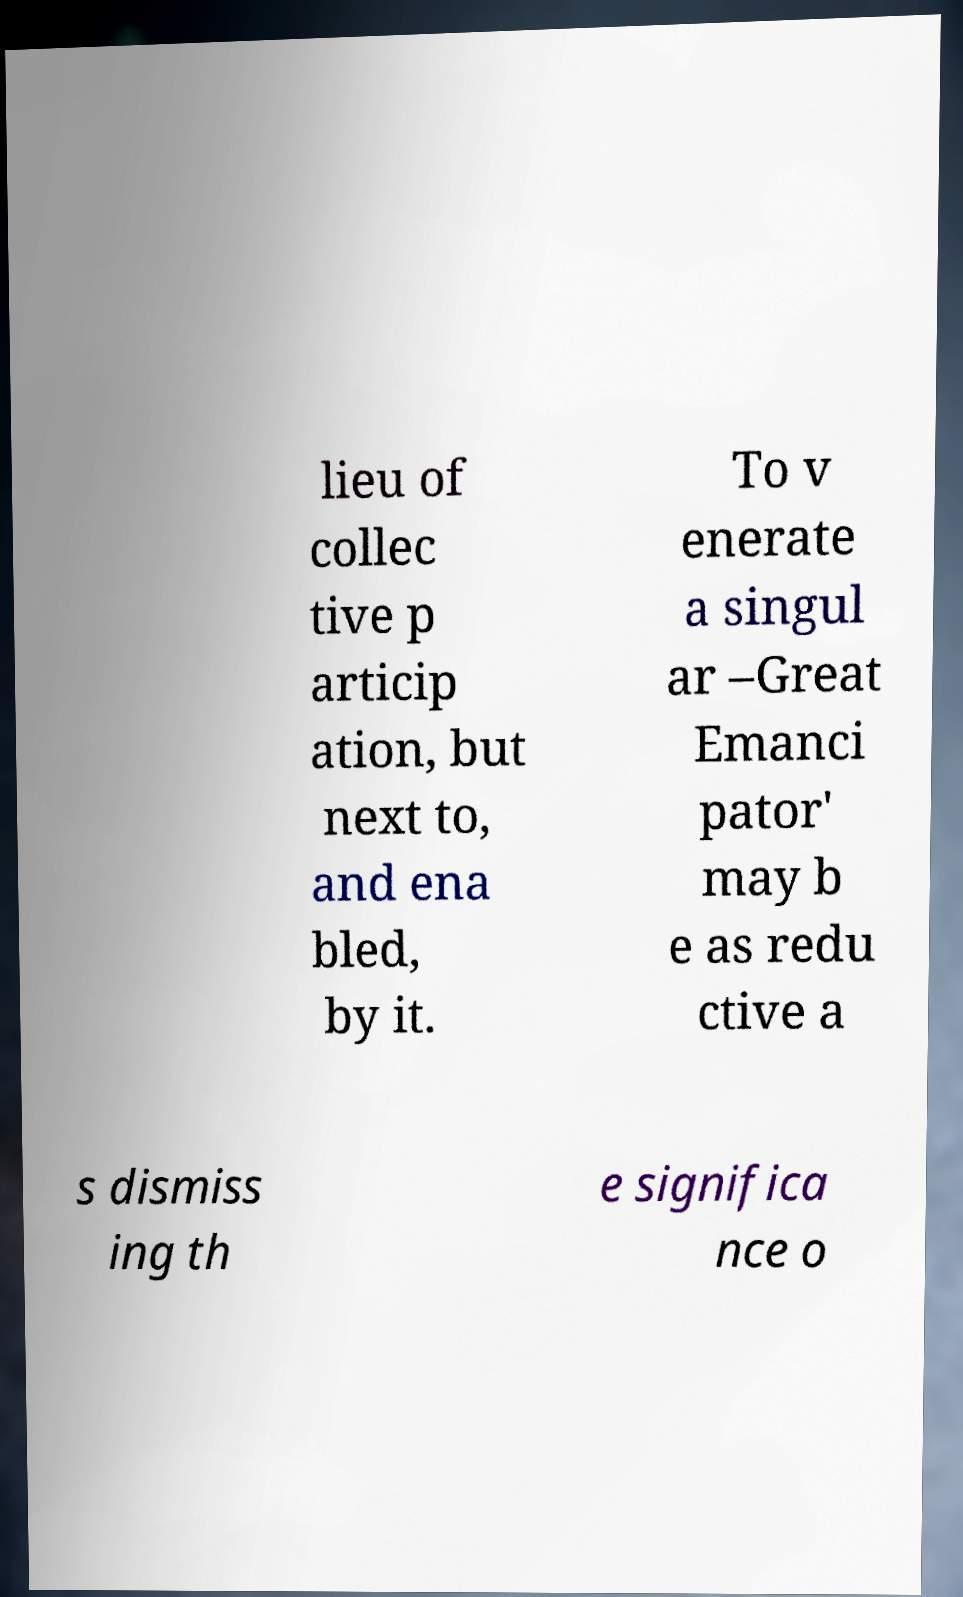What messages or text are displayed in this image? I need them in a readable, typed format. lieu of collec tive p articip ation, but next to, and ena bled, by it. To v enerate a singul ar –Great Emanci pator' may b e as redu ctive a s dismiss ing th e significa nce o 